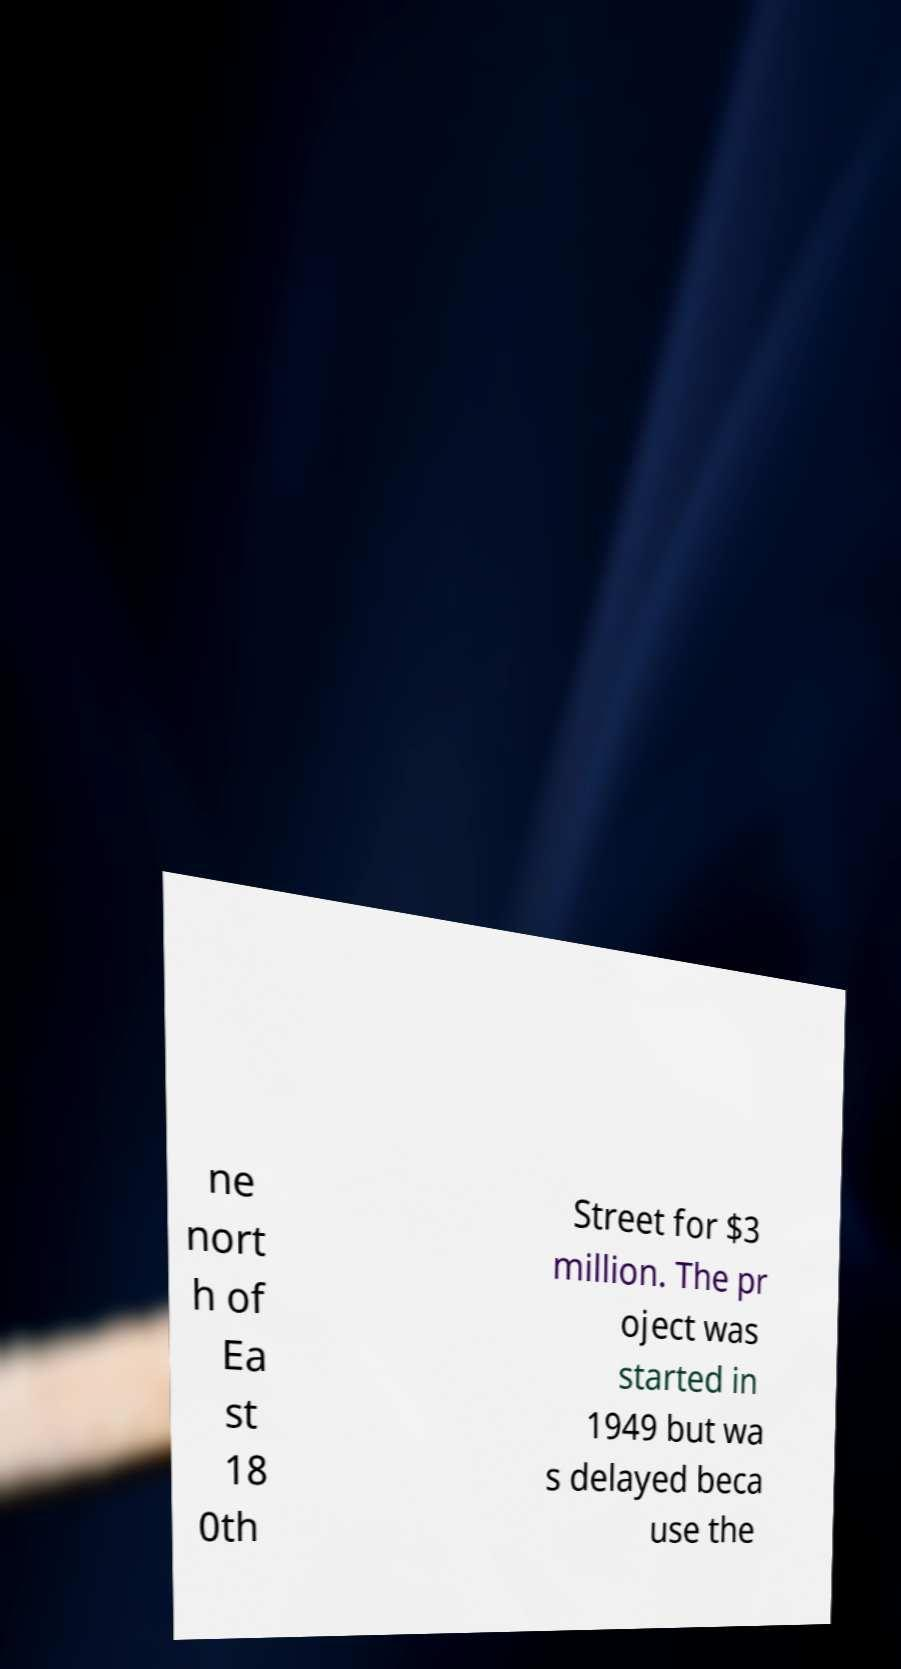Can you accurately transcribe the text from the provided image for me? ne nort h of Ea st 18 0th Street for $3 million. The pr oject was started in 1949 but wa s delayed beca use the 